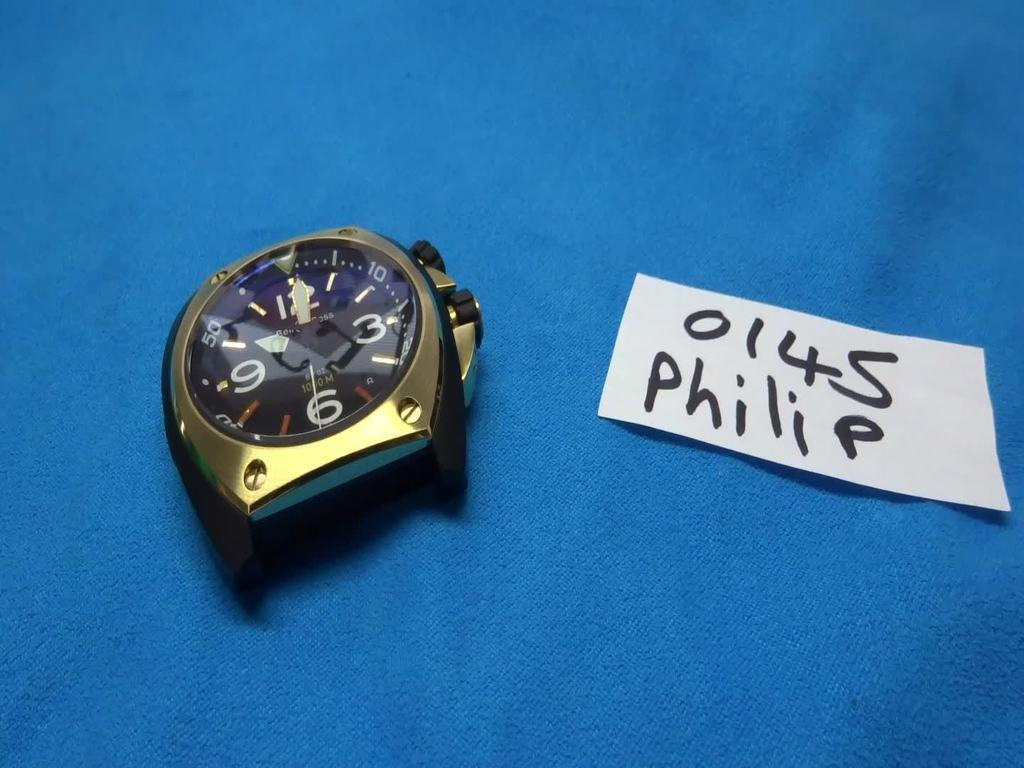<image>
Summarize the visual content of the image. Face of a watch next to a piece of paper which says Philip on it. 